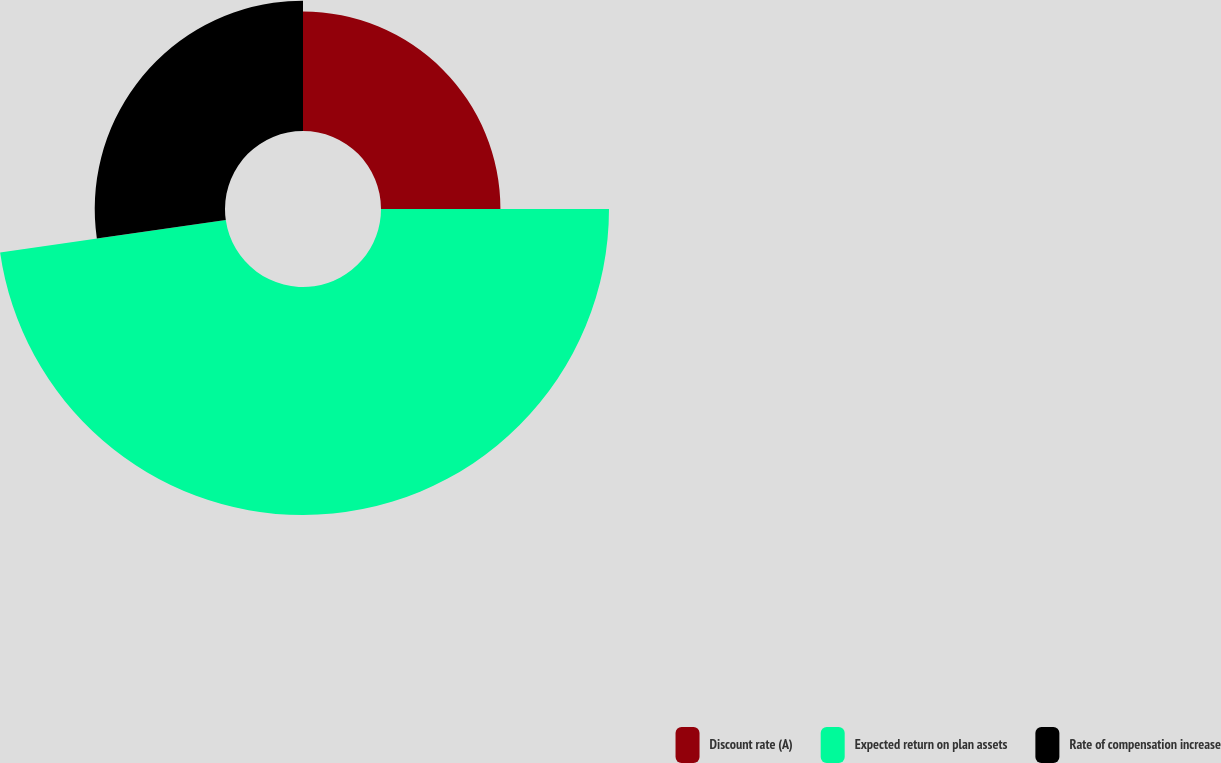<chart> <loc_0><loc_0><loc_500><loc_500><pie_chart><fcel>Discount rate (A)<fcel>Expected return on plan assets<fcel>Rate of compensation increase<nl><fcel>25.0%<fcel>47.73%<fcel>27.27%<nl></chart> 